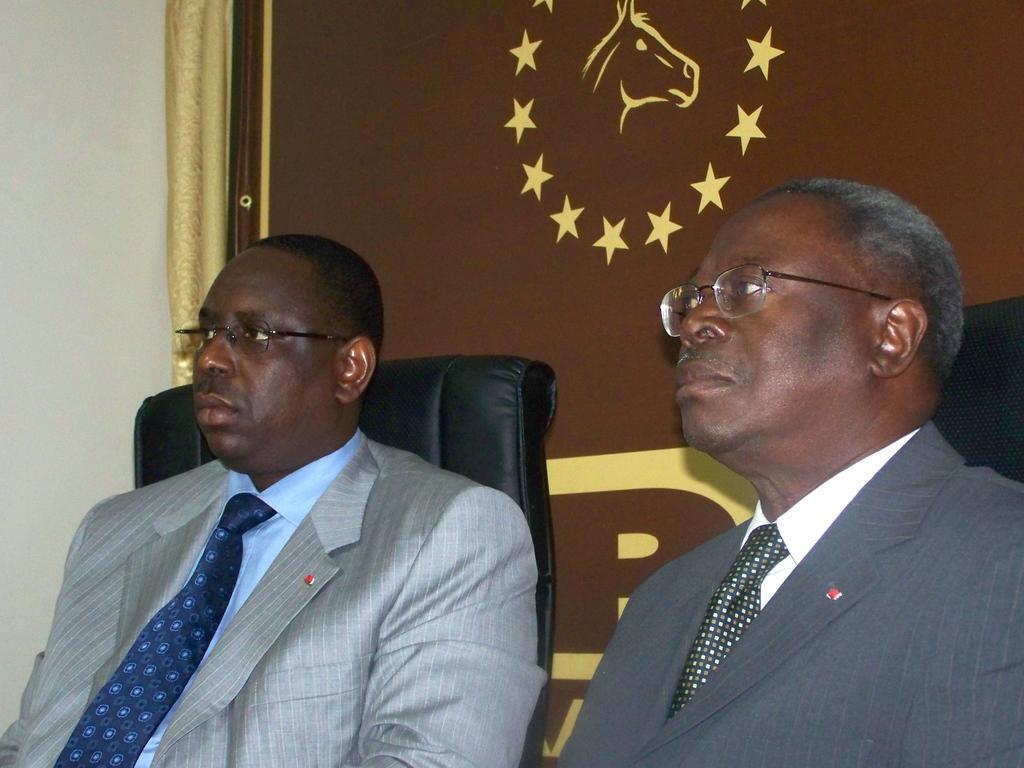How would you summarize this image in a sentence or two? In the center of the image there are two persons sitting on chairs. In the background of the image there is a wall. 